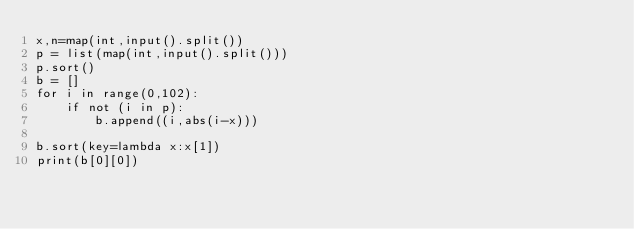Convert code to text. <code><loc_0><loc_0><loc_500><loc_500><_Python_>x,n=map(int,input().split())
p = list(map(int,input().split()))
p.sort()
b = []
for i in range(0,102):
    if not (i in p):
        b.append((i,abs(i-x)))

b.sort(key=lambda x:x[1])
print(b[0][0])</code> 